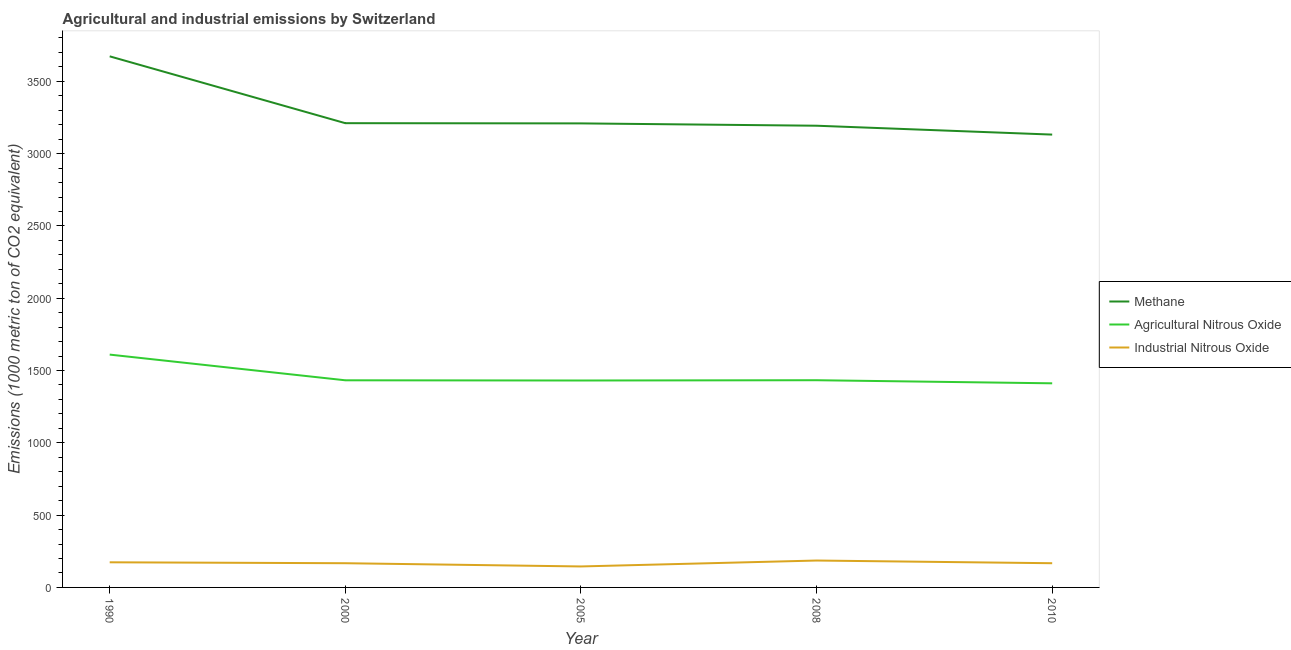What is the amount of methane emissions in 2000?
Make the answer very short. 3210.7. Across all years, what is the maximum amount of industrial nitrous oxide emissions?
Offer a terse response. 186. Across all years, what is the minimum amount of methane emissions?
Offer a very short reply. 3131.7. In which year was the amount of industrial nitrous oxide emissions maximum?
Give a very brief answer. 2008. What is the total amount of methane emissions in the graph?
Provide a succinct answer. 1.64e+04. What is the difference between the amount of industrial nitrous oxide emissions in 2008 and the amount of methane emissions in 2005?
Give a very brief answer. -3023.2. What is the average amount of industrial nitrous oxide emissions per year?
Your answer should be very brief. 167.94. In the year 1990, what is the difference between the amount of methane emissions and amount of agricultural nitrous oxide emissions?
Give a very brief answer. 2062.8. In how many years, is the amount of agricultural nitrous oxide emissions greater than 3200 metric ton?
Provide a succinct answer. 0. What is the ratio of the amount of methane emissions in 2005 to that in 2008?
Your response must be concise. 1.01. Is the amount of methane emissions in 2008 less than that in 2010?
Give a very brief answer. No. Is the difference between the amount of industrial nitrous oxide emissions in 1990 and 2008 greater than the difference between the amount of agricultural nitrous oxide emissions in 1990 and 2008?
Give a very brief answer. No. What is the difference between the highest and the second highest amount of industrial nitrous oxide emissions?
Give a very brief answer. 12.2. What is the difference between the highest and the lowest amount of agricultural nitrous oxide emissions?
Offer a very short reply. 198.6. In how many years, is the amount of methane emissions greater than the average amount of methane emissions taken over all years?
Make the answer very short. 1. Is it the case that in every year, the sum of the amount of methane emissions and amount of agricultural nitrous oxide emissions is greater than the amount of industrial nitrous oxide emissions?
Your response must be concise. Yes. Does the amount of methane emissions monotonically increase over the years?
Your answer should be compact. No. Is the amount of industrial nitrous oxide emissions strictly less than the amount of methane emissions over the years?
Provide a succinct answer. Yes. What is the difference between two consecutive major ticks on the Y-axis?
Provide a short and direct response. 500. Does the graph contain grids?
Your response must be concise. No. Where does the legend appear in the graph?
Your answer should be compact. Center right. What is the title of the graph?
Ensure brevity in your answer.  Agricultural and industrial emissions by Switzerland. What is the label or title of the X-axis?
Make the answer very short. Year. What is the label or title of the Y-axis?
Make the answer very short. Emissions (1000 metric ton of CO2 equivalent). What is the Emissions (1000 metric ton of CO2 equivalent) in Methane in 1990?
Your response must be concise. 3673. What is the Emissions (1000 metric ton of CO2 equivalent) in Agricultural Nitrous Oxide in 1990?
Your answer should be very brief. 1610.2. What is the Emissions (1000 metric ton of CO2 equivalent) of Industrial Nitrous Oxide in 1990?
Ensure brevity in your answer.  173.8. What is the Emissions (1000 metric ton of CO2 equivalent) in Methane in 2000?
Your response must be concise. 3210.7. What is the Emissions (1000 metric ton of CO2 equivalent) of Agricultural Nitrous Oxide in 2000?
Make the answer very short. 1432.5. What is the Emissions (1000 metric ton of CO2 equivalent) in Industrial Nitrous Oxide in 2000?
Ensure brevity in your answer.  167.4. What is the Emissions (1000 metric ton of CO2 equivalent) in Methane in 2005?
Keep it short and to the point. 3209.2. What is the Emissions (1000 metric ton of CO2 equivalent) of Agricultural Nitrous Oxide in 2005?
Your answer should be compact. 1431.1. What is the Emissions (1000 metric ton of CO2 equivalent) in Industrial Nitrous Oxide in 2005?
Provide a short and direct response. 145.1. What is the Emissions (1000 metric ton of CO2 equivalent) of Methane in 2008?
Provide a short and direct response. 3193.1. What is the Emissions (1000 metric ton of CO2 equivalent) of Agricultural Nitrous Oxide in 2008?
Your response must be concise. 1433. What is the Emissions (1000 metric ton of CO2 equivalent) of Industrial Nitrous Oxide in 2008?
Provide a short and direct response. 186. What is the Emissions (1000 metric ton of CO2 equivalent) in Methane in 2010?
Provide a short and direct response. 3131.7. What is the Emissions (1000 metric ton of CO2 equivalent) of Agricultural Nitrous Oxide in 2010?
Make the answer very short. 1411.6. What is the Emissions (1000 metric ton of CO2 equivalent) of Industrial Nitrous Oxide in 2010?
Provide a succinct answer. 167.4. Across all years, what is the maximum Emissions (1000 metric ton of CO2 equivalent) in Methane?
Provide a short and direct response. 3673. Across all years, what is the maximum Emissions (1000 metric ton of CO2 equivalent) of Agricultural Nitrous Oxide?
Your response must be concise. 1610.2. Across all years, what is the maximum Emissions (1000 metric ton of CO2 equivalent) of Industrial Nitrous Oxide?
Give a very brief answer. 186. Across all years, what is the minimum Emissions (1000 metric ton of CO2 equivalent) of Methane?
Offer a terse response. 3131.7. Across all years, what is the minimum Emissions (1000 metric ton of CO2 equivalent) of Agricultural Nitrous Oxide?
Your answer should be very brief. 1411.6. Across all years, what is the minimum Emissions (1000 metric ton of CO2 equivalent) in Industrial Nitrous Oxide?
Give a very brief answer. 145.1. What is the total Emissions (1000 metric ton of CO2 equivalent) of Methane in the graph?
Ensure brevity in your answer.  1.64e+04. What is the total Emissions (1000 metric ton of CO2 equivalent) in Agricultural Nitrous Oxide in the graph?
Ensure brevity in your answer.  7318.4. What is the total Emissions (1000 metric ton of CO2 equivalent) in Industrial Nitrous Oxide in the graph?
Provide a short and direct response. 839.7. What is the difference between the Emissions (1000 metric ton of CO2 equivalent) in Methane in 1990 and that in 2000?
Your response must be concise. 462.3. What is the difference between the Emissions (1000 metric ton of CO2 equivalent) of Agricultural Nitrous Oxide in 1990 and that in 2000?
Give a very brief answer. 177.7. What is the difference between the Emissions (1000 metric ton of CO2 equivalent) of Industrial Nitrous Oxide in 1990 and that in 2000?
Give a very brief answer. 6.4. What is the difference between the Emissions (1000 metric ton of CO2 equivalent) in Methane in 1990 and that in 2005?
Your answer should be very brief. 463.8. What is the difference between the Emissions (1000 metric ton of CO2 equivalent) in Agricultural Nitrous Oxide in 1990 and that in 2005?
Your answer should be compact. 179.1. What is the difference between the Emissions (1000 metric ton of CO2 equivalent) in Industrial Nitrous Oxide in 1990 and that in 2005?
Provide a short and direct response. 28.7. What is the difference between the Emissions (1000 metric ton of CO2 equivalent) in Methane in 1990 and that in 2008?
Give a very brief answer. 479.9. What is the difference between the Emissions (1000 metric ton of CO2 equivalent) of Agricultural Nitrous Oxide in 1990 and that in 2008?
Make the answer very short. 177.2. What is the difference between the Emissions (1000 metric ton of CO2 equivalent) of Methane in 1990 and that in 2010?
Provide a short and direct response. 541.3. What is the difference between the Emissions (1000 metric ton of CO2 equivalent) of Agricultural Nitrous Oxide in 1990 and that in 2010?
Provide a succinct answer. 198.6. What is the difference between the Emissions (1000 metric ton of CO2 equivalent) of Methane in 2000 and that in 2005?
Your response must be concise. 1.5. What is the difference between the Emissions (1000 metric ton of CO2 equivalent) of Agricultural Nitrous Oxide in 2000 and that in 2005?
Give a very brief answer. 1.4. What is the difference between the Emissions (1000 metric ton of CO2 equivalent) of Industrial Nitrous Oxide in 2000 and that in 2005?
Provide a short and direct response. 22.3. What is the difference between the Emissions (1000 metric ton of CO2 equivalent) of Methane in 2000 and that in 2008?
Provide a succinct answer. 17.6. What is the difference between the Emissions (1000 metric ton of CO2 equivalent) of Agricultural Nitrous Oxide in 2000 and that in 2008?
Make the answer very short. -0.5. What is the difference between the Emissions (1000 metric ton of CO2 equivalent) in Industrial Nitrous Oxide in 2000 and that in 2008?
Your answer should be very brief. -18.6. What is the difference between the Emissions (1000 metric ton of CO2 equivalent) of Methane in 2000 and that in 2010?
Give a very brief answer. 79. What is the difference between the Emissions (1000 metric ton of CO2 equivalent) of Agricultural Nitrous Oxide in 2000 and that in 2010?
Offer a very short reply. 20.9. What is the difference between the Emissions (1000 metric ton of CO2 equivalent) of Industrial Nitrous Oxide in 2005 and that in 2008?
Make the answer very short. -40.9. What is the difference between the Emissions (1000 metric ton of CO2 equivalent) in Methane in 2005 and that in 2010?
Make the answer very short. 77.5. What is the difference between the Emissions (1000 metric ton of CO2 equivalent) in Agricultural Nitrous Oxide in 2005 and that in 2010?
Offer a very short reply. 19.5. What is the difference between the Emissions (1000 metric ton of CO2 equivalent) of Industrial Nitrous Oxide in 2005 and that in 2010?
Your answer should be very brief. -22.3. What is the difference between the Emissions (1000 metric ton of CO2 equivalent) of Methane in 2008 and that in 2010?
Your response must be concise. 61.4. What is the difference between the Emissions (1000 metric ton of CO2 equivalent) in Agricultural Nitrous Oxide in 2008 and that in 2010?
Provide a succinct answer. 21.4. What is the difference between the Emissions (1000 metric ton of CO2 equivalent) of Industrial Nitrous Oxide in 2008 and that in 2010?
Your response must be concise. 18.6. What is the difference between the Emissions (1000 metric ton of CO2 equivalent) in Methane in 1990 and the Emissions (1000 metric ton of CO2 equivalent) in Agricultural Nitrous Oxide in 2000?
Your answer should be very brief. 2240.5. What is the difference between the Emissions (1000 metric ton of CO2 equivalent) in Methane in 1990 and the Emissions (1000 metric ton of CO2 equivalent) in Industrial Nitrous Oxide in 2000?
Your answer should be compact. 3505.6. What is the difference between the Emissions (1000 metric ton of CO2 equivalent) of Agricultural Nitrous Oxide in 1990 and the Emissions (1000 metric ton of CO2 equivalent) of Industrial Nitrous Oxide in 2000?
Your answer should be very brief. 1442.8. What is the difference between the Emissions (1000 metric ton of CO2 equivalent) in Methane in 1990 and the Emissions (1000 metric ton of CO2 equivalent) in Agricultural Nitrous Oxide in 2005?
Offer a very short reply. 2241.9. What is the difference between the Emissions (1000 metric ton of CO2 equivalent) of Methane in 1990 and the Emissions (1000 metric ton of CO2 equivalent) of Industrial Nitrous Oxide in 2005?
Provide a succinct answer. 3527.9. What is the difference between the Emissions (1000 metric ton of CO2 equivalent) of Agricultural Nitrous Oxide in 1990 and the Emissions (1000 metric ton of CO2 equivalent) of Industrial Nitrous Oxide in 2005?
Your response must be concise. 1465.1. What is the difference between the Emissions (1000 metric ton of CO2 equivalent) of Methane in 1990 and the Emissions (1000 metric ton of CO2 equivalent) of Agricultural Nitrous Oxide in 2008?
Offer a very short reply. 2240. What is the difference between the Emissions (1000 metric ton of CO2 equivalent) of Methane in 1990 and the Emissions (1000 metric ton of CO2 equivalent) of Industrial Nitrous Oxide in 2008?
Ensure brevity in your answer.  3487. What is the difference between the Emissions (1000 metric ton of CO2 equivalent) in Agricultural Nitrous Oxide in 1990 and the Emissions (1000 metric ton of CO2 equivalent) in Industrial Nitrous Oxide in 2008?
Ensure brevity in your answer.  1424.2. What is the difference between the Emissions (1000 metric ton of CO2 equivalent) of Methane in 1990 and the Emissions (1000 metric ton of CO2 equivalent) of Agricultural Nitrous Oxide in 2010?
Provide a short and direct response. 2261.4. What is the difference between the Emissions (1000 metric ton of CO2 equivalent) in Methane in 1990 and the Emissions (1000 metric ton of CO2 equivalent) in Industrial Nitrous Oxide in 2010?
Provide a short and direct response. 3505.6. What is the difference between the Emissions (1000 metric ton of CO2 equivalent) of Agricultural Nitrous Oxide in 1990 and the Emissions (1000 metric ton of CO2 equivalent) of Industrial Nitrous Oxide in 2010?
Your answer should be compact. 1442.8. What is the difference between the Emissions (1000 metric ton of CO2 equivalent) in Methane in 2000 and the Emissions (1000 metric ton of CO2 equivalent) in Agricultural Nitrous Oxide in 2005?
Give a very brief answer. 1779.6. What is the difference between the Emissions (1000 metric ton of CO2 equivalent) in Methane in 2000 and the Emissions (1000 metric ton of CO2 equivalent) in Industrial Nitrous Oxide in 2005?
Your answer should be compact. 3065.6. What is the difference between the Emissions (1000 metric ton of CO2 equivalent) in Agricultural Nitrous Oxide in 2000 and the Emissions (1000 metric ton of CO2 equivalent) in Industrial Nitrous Oxide in 2005?
Provide a short and direct response. 1287.4. What is the difference between the Emissions (1000 metric ton of CO2 equivalent) of Methane in 2000 and the Emissions (1000 metric ton of CO2 equivalent) of Agricultural Nitrous Oxide in 2008?
Offer a very short reply. 1777.7. What is the difference between the Emissions (1000 metric ton of CO2 equivalent) of Methane in 2000 and the Emissions (1000 metric ton of CO2 equivalent) of Industrial Nitrous Oxide in 2008?
Ensure brevity in your answer.  3024.7. What is the difference between the Emissions (1000 metric ton of CO2 equivalent) in Agricultural Nitrous Oxide in 2000 and the Emissions (1000 metric ton of CO2 equivalent) in Industrial Nitrous Oxide in 2008?
Offer a very short reply. 1246.5. What is the difference between the Emissions (1000 metric ton of CO2 equivalent) of Methane in 2000 and the Emissions (1000 metric ton of CO2 equivalent) of Agricultural Nitrous Oxide in 2010?
Give a very brief answer. 1799.1. What is the difference between the Emissions (1000 metric ton of CO2 equivalent) of Methane in 2000 and the Emissions (1000 metric ton of CO2 equivalent) of Industrial Nitrous Oxide in 2010?
Make the answer very short. 3043.3. What is the difference between the Emissions (1000 metric ton of CO2 equivalent) in Agricultural Nitrous Oxide in 2000 and the Emissions (1000 metric ton of CO2 equivalent) in Industrial Nitrous Oxide in 2010?
Provide a succinct answer. 1265.1. What is the difference between the Emissions (1000 metric ton of CO2 equivalent) in Methane in 2005 and the Emissions (1000 metric ton of CO2 equivalent) in Agricultural Nitrous Oxide in 2008?
Provide a succinct answer. 1776.2. What is the difference between the Emissions (1000 metric ton of CO2 equivalent) of Methane in 2005 and the Emissions (1000 metric ton of CO2 equivalent) of Industrial Nitrous Oxide in 2008?
Provide a succinct answer. 3023.2. What is the difference between the Emissions (1000 metric ton of CO2 equivalent) of Agricultural Nitrous Oxide in 2005 and the Emissions (1000 metric ton of CO2 equivalent) of Industrial Nitrous Oxide in 2008?
Offer a terse response. 1245.1. What is the difference between the Emissions (1000 metric ton of CO2 equivalent) in Methane in 2005 and the Emissions (1000 metric ton of CO2 equivalent) in Agricultural Nitrous Oxide in 2010?
Provide a succinct answer. 1797.6. What is the difference between the Emissions (1000 metric ton of CO2 equivalent) in Methane in 2005 and the Emissions (1000 metric ton of CO2 equivalent) in Industrial Nitrous Oxide in 2010?
Offer a very short reply. 3041.8. What is the difference between the Emissions (1000 metric ton of CO2 equivalent) of Agricultural Nitrous Oxide in 2005 and the Emissions (1000 metric ton of CO2 equivalent) of Industrial Nitrous Oxide in 2010?
Your answer should be compact. 1263.7. What is the difference between the Emissions (1000 metric ton of CO2 equivalent) in Methane in 2008 and the Emissions (1000 metric ton of CO2 equivalent) in Agricultural Nitrous Oxide in 2010?
Keep it short and to the point. 1781.5. What is the difference between the Emissions (1000 metric ton of CO2 equivalent) of Methane in 2008 and the Emissions (1000 metric ton of CO2 equivalent) of Industrial Nitrous Oxide in 2010?
Offer a terse response. 3025.7. What is the difference between the Emissions (1000 metric ton of CO2 equivalent) of Agricultural Nitrous Oxide in 2008 and the Emissions (1000 metric ton of CO2 equivalent) of Industrial Nitrous Oxide in 2010?
Your answer should be compact. 1265.6. What is the average Emissions (1000 metric ton of CO2 equivalent) in Methane per year?
Provide a succinct answer. 3283.54. What is the average Emissions (1000 metric ton of CO2 equivalent) in Agricultural Nitrous Oxide per year?
Provide a short and direct response. 1463.68. What is the average Emissions (1000 metric ton of CO2 equivalent) in Industrial Nitrous Oxide per year?
Provide a short and direct response. 167.94. In the year 1990, what is the difference between the Emissions (1000 metric ton of CO2 equivalent) in Methane and Emissions (1000 metric ton of CO2 equivalent) in Agricultural Nitrous Oxide?
Offer a very short reply. 2062.8. In the year 1990, what is the difference between the Emissions (1000 metric ton of CO2 equivalent) of Methane and Emissions (1000 metric ton of CO2 equivalent) of Industrial Nitrous Oxide?
Offer a very short reply. 3499.2. In the year 1990, what is the difference between the Emissions (1000 metric ton of CO2 equivalent) in Agricultural Nitrous Oxide and Emissions (1000 metric ton of CO2 equivalent) in Industrial Nitrous Oxide?
Provide a short and direct response. 1436.4. In the year 2000, what is the difference between the Emissions (1000 metric ton of CO2 equivalent) in Methane and Emissions (1000 metric ton of CO2 equivalent) in Agricultural Nitrous Oxide?
Your answer should be very brief. 1778.2. In the year 2000, what is the difference between the Emissions (1000 metric ton of CO2 equivalent) of Methane and Emissions (1000 metric ton of CO2 equivalent) of Industrial Nitrous Oxide?
Your answer should be very brief. 3043.3. In the year 2000, what is the difference between the Emissions (1000 metric ton of CO2 equivalent) of Agricultural Nitrous Oxide and Emissions (1000 metric ton of CO2 equivalent) of Industrial Nitrous Oxide?
Your answer should be compact. 1265.1. In the year 2005, what is the difference between the Emissions (1000 metric ton of CO2 equivalent) in Methane and Emissions (1000 metric ton of CO2 equivalent) in Agricultural Nitrous Oxide?
Keep it short and to the point. 1778.1. In the year 2005, what is the difference between the Emissions (1000 metric ton of CO2 equivalent) in Methane and Emissions (1000 metric ton of CO2 equivalent) in Industrial Nitrous Oxide?
Provide a short and direct response. 3064.1. In the year 2005, what is the difference between the Emissions (1000 metric ton of CO2 equivalent) in Agricultural Nitrous Oxide and Emissions (1000 metric ton of CO2 equivalent) in Industrial Nitrous Oxide?
Offer a very short reply. 1286. In the year 2008, what is the difference between the Emissions (1000 metric ton of CO2 equivalent) of Methane and Emissions (1000 metric ton of CO2 equivalent) of Agricultural Nitrous Oxide?
Your answer should be very brief. 1760.1. In the year 2008, what is the difference between the Emissions (1000 metric ton of CO2 equivalent) in Methane and Emissions (1000 metric ton of CO2 equivalent) in Industrial Nitrous Oxide?
Give a very brief answer. 3007.1. In the year 2008, what is the difference between the Emissions (1000 metric ton of CO2 equivalent) of Agricultural Nitrous Oxide and Emissions (1000 metric ton of CO2 equivalent) of Industrial Nitrous Oxide?
Offer a very short reply. 1247. In the year 2010, what is the difference between the Emissions (1000 metric ton of CO2 equivalent) in Methane and Emissions (1000 metric ton of CO2 equivalent) in Agricultural Nitrous Oxide?
Offer a very short reply. 1720.1. In the year 2010, what is the difference between the Emissions (1000 metric ton of CO2 equivalent) in Methane and Emissions (1000 metric ton of CO2 equivalent) in Industrial Nitrous Oxide?
Keep it short and to the point. 2964.3. In the year 2010, what is the difference between the Emissions (1000 metric ton of CO2 equivalent) in Agricultural Nitrous Oxide and Emissions (1000 metric ton of CO2 equivalent) in Industrial Nitrous Oxide?
Your answer should be very brief. 1244.2. What is the ratio of the Emissions (1000 metric ton of CO2 equivalent) of Methane in 1990 to that in 2000?
Offer a very short reply. 1.14. What is the ratio of the Emissions (1000 metric ton of CO2 equivalent) of Agricultural Nitrous Oxide in 1990 to that in 2000?
Give a very brief answer. 1.12. What is the ratio of the Emissions (1000 metric ton of CO2 equivalent) of Industrial Nitrous Oxide in 1990 to that in 2000?
Your response must be concise. 1.04. What is the ratio of the Emissions (1000 metric ton of CO2 equivalent) in Methane in 1990 to that in 2005?
Ensure brevity in your answer.  1.14. What is the ratio of the Emissions (1000 metric ton of CO2 equivalent) in Agricultural Nitrous Oxide in 1990 to that in 2005?
Your response must be concise. 1.13. What is the ratio of the Emissions (1000 metric ton of CO2 equivalent) of Industrial Nitrous Oxide in 1990 to that in 2005?
Make the answer very short. 1.2. What is the ratio of the Emissions (1000 metric ton of CO2 equivalent) in Methane in 1990 to that in 2008?
Provide a short and direct response. 1.15. What is the ratio of the Emissions (1000 metric ton of CO2 equivalent) of Agricultural Nitrous Oxide in 1990 to that in 2008?
Make the answer very short. 1.12. What is the ratio of the Emissions (1000 metric ton of CO2 equivalent) of Industrial Nitrous Oxide in 1990 to that in 2008?
Offer a terse response. 0.93. What is the ratio of the Emissions (1000 metric ton of CO2 equivalent) in Methane in 1990 to that in 2010?
Offer a terse response. 1.17. What is the ratio of the Emissions (1000 metric ton of CO2 equivalent) in Agricultural Nitrous Oxide in 1990 to that in 2010?
Offer a very short reply. 1.14. What is the ratio of the Emissions (1000 metric ton of CO2 equivalent) of Industrial Nitrous Oxide in 1990 to that in 2010?
Your answer should be very brief. 1.04. What is the ratio of the Emissions (1000 metric ton of CO2 equivalent) in Methane in 2000 to that in 2005?
Your answer should be very brief. 1. What is the ratio of the Emissions (1000 metric ton of CO2 equivalent) in Industrial Nitrous Oxide in 2000 to that in 2005?
Your answer should be compact. 1.15. What is the ratio of the Emissions (1000 metric ton of CO2 equivalent) of Agricultural Nitrous Oxide in 2000 to that in 2008?
Keep it short and to the point. 1. What is the ratio of the Emissions (1000 metric ton of CO2 equivalent) in Methane in 2000 to that in 2010?
Provide a short and direct response. 1.03. What is the ratio of the Emissions (1000 metric ton of CO2 equivalent) in Agricultural Nitrous Oxide in 2000 to that in 2010?
Give a very brief answer. 1.01. What is the ratio of the Emissions (1000 metric ton of CO2 equivalent) of Methane in 2005 to that in 2008?
Give a very brief answer. 1. What is the ratio of the Emissions (1000 metric ton of CO2 equivalent) in Agricultural Nitrous Oxide in 2005 to that in 2008?
Provide a short and direct response. 1. What is the ratio of the Emissions (1000 metric ton of CO2 equivalent) of Industrial Nitrous Oxide in 2005 to that in 2008?
Ensure brevity in your answer.  0.78. What is the ratio of the Emissions (1000 metric ton of CO2 equivalent) of Methane in 2005 to that in 2010?
Make the answer very short. 1.02. What is the ratio of the Emissions (1000 metric ton of CO2 equivalent) of Agricultural Nitrous Oxide in 2005 to that in 2010?
Your response must be concise. 1.01. What is the ratio of the Emissions (1000 metric ton of CO2 equivalent) in Industrial Nitrous Oxide in 2005 to that in 2010?
Ensure brevity in your answer.  0.87. What is the ratio of the Emissions (1000 metric ton of CO2 equivalent) in Methane in 2008 to that in 2010?
Provide a short and direct response. 1.02. What is the ratio of the Emissions (1000 metric ton of CO2 equivalent) of Agricultural Nitrous Oxide in 2008 to that in 2010?
Offer a terse response. 1.02. What is the ratio of the Emissions (1000 metric ton of CO2 equivalent) in Industrial Nitrous Oxide in 2008 to that in 2010?
Make the answer very short. 1.11. What is the difference between the highest and the second highest Emissions (1000 metric ton of CO2 equivalent) of Methane?
Offer a very short reply. 462.3. What is the difference between the highest and the second highest Emissions (1000 metric ton of CO2 equivalent) in Agricultural Nitrous Oxide?
Ensure brevity in your answer.  177.2. What is the difference between the highest and the second highest Emissions (1000 metric ton of CO2 equivalent) of Industrial Nitrous Oxide?
Keep it short and to the point. 12.2. What is the difference between the highest and the lowest Emissions (1000 metric ton of CO2 equivalent) in Methane?
Give a very brief answer. 541.3. What is the difference between the highest and the lowest Emissions (1000 metric ton of CO2 equivalent) of Agricultural Nitrous Oxide?
Give a very brief answer. 198.6. What is the difference between the highest and the lowest Emissions (1000 metric ton of CO2 equivalent) in Industrial Nitrous Oxide?
Your response must be concise. 40.9. 